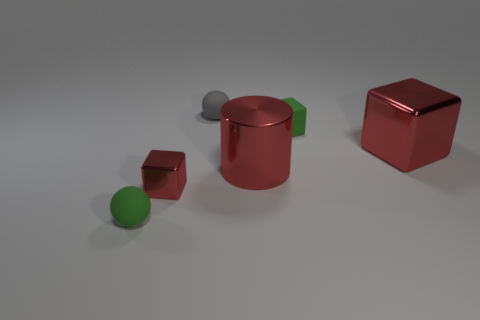Subtract all shiny cubes. How many cubes are left? 1 Subtract all red cubes. How many cubes are left? 1 Add 1 big red objects. How many big red objects are left? 3 Add 6 tiny blue cylinders. How many tiny blue cylinders exist? 6 Add 2 metal cylinders. How many objects exist? 8 Subtract 0 blue cylinders. How many objects are left? 6 Subtract all spheres. How many objects are left? 4 Subtract 2 cubes. How many cubes are left? 1 Subtract all gray cylinders. Subtract all green blocks. How many cylinders are left? 1 Subtract all yellow spheres. How many brown blocks are left? 0 